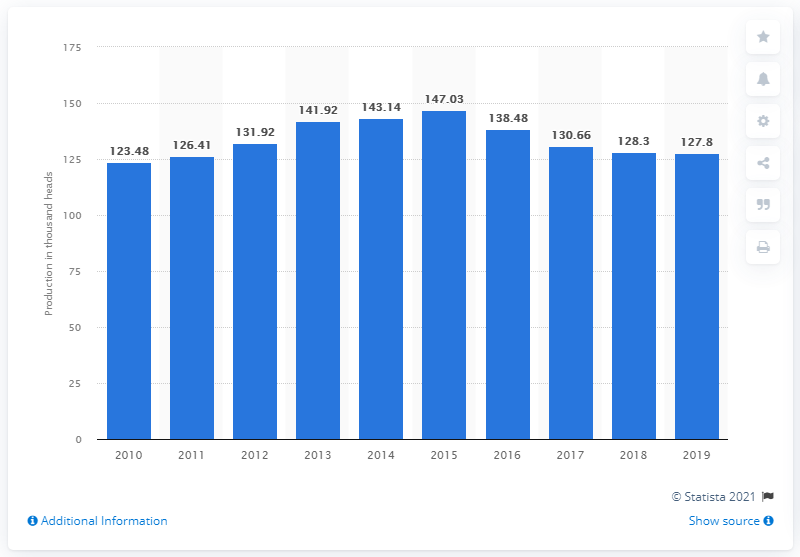Identify some key points in this picture. In the year 2015, Malaysia achieved the highest sheep production. 